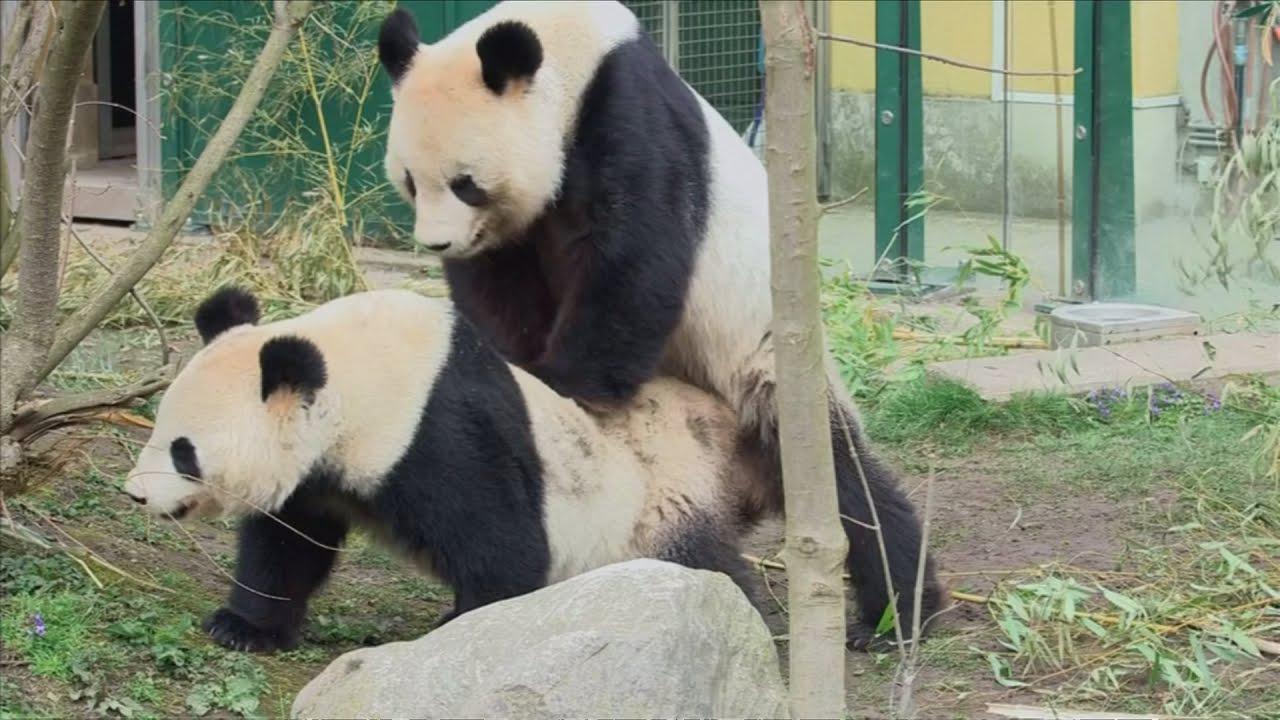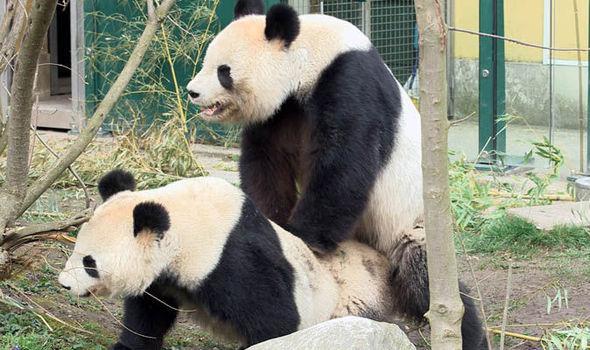The first image is the image on the left, the second image is the image on the right. Assess this claim about the two images: "there are pandas mating next to a rock which is next to a tree trunk with windowed fencing and green posts in the back ground". Correct or not? Answer yes or no. Yes. The first image is the image on the left, the second image is the image on the right. For the images shown, is this caption "One image shows a panda with its front paws on a large tree trunk, and the other image shows two pandas, one on top with its front paws on the other." true? Answer yes or no. No. 